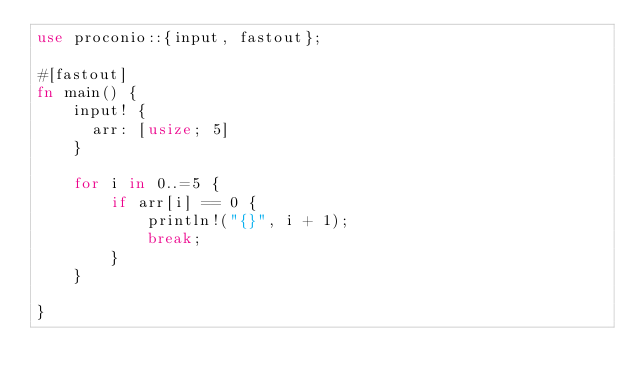Convert code to text. <code><loc_0><loc_0><loc_500><loc_500><_Rust_>use proconio::{input, fastout};

#[fastout]
fn main() {
    input! {
      arr: [usize; 5]
    }

    for i in 0..=5 {
        if arr[i] == 0 {
            println!("{}", i + 1);
            break;
        }
    }

}
</code> 